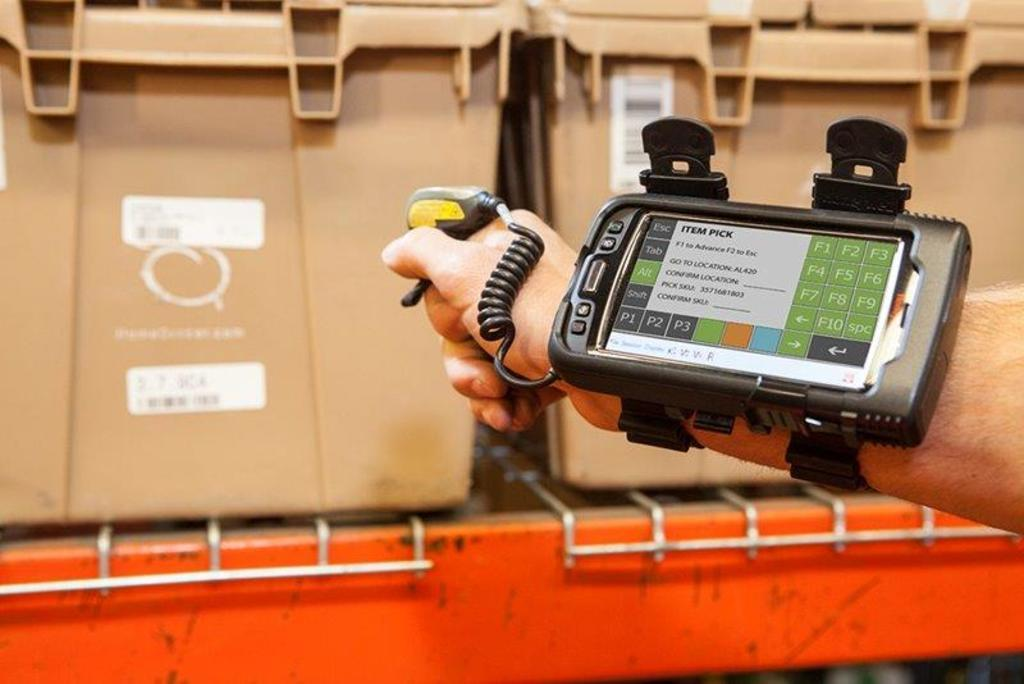<image>
Provide a brief description of the given image. A worker wears a device that allows a scanner to be attached to his arm for the item pick. 